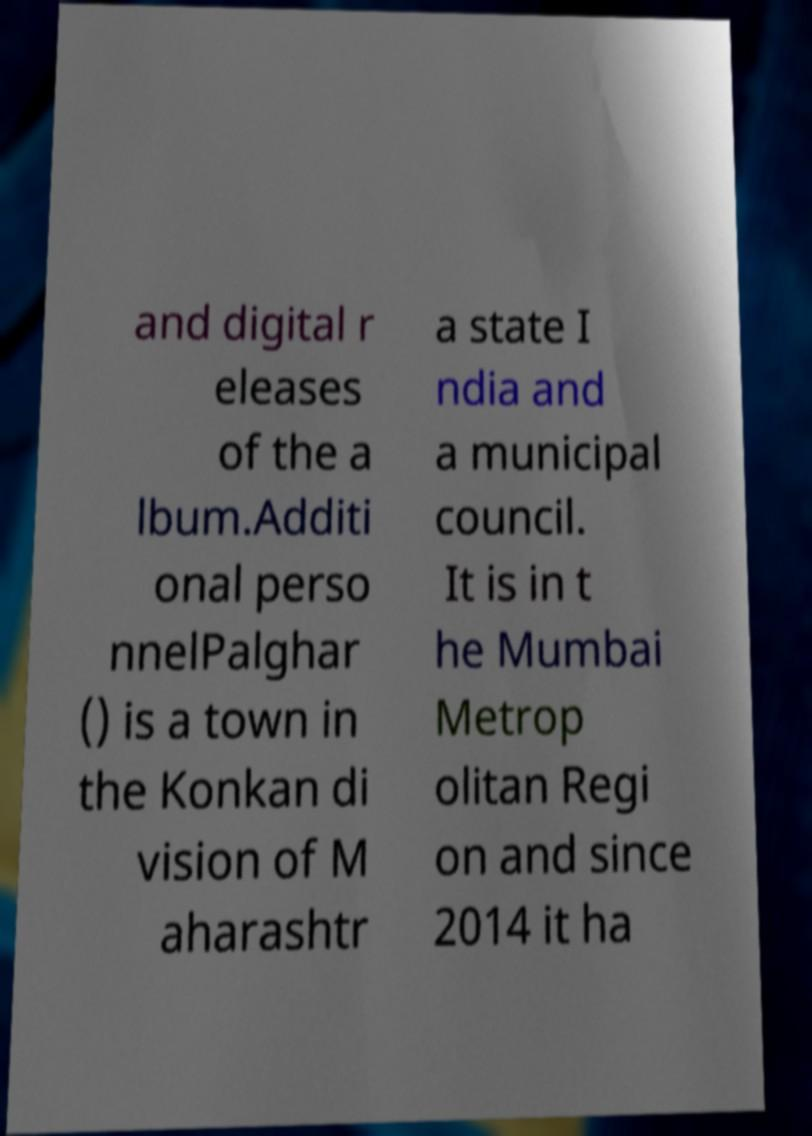There's text embedded in this image that I need extracted. Can you transcribe it verbatim? and digital r eleases of the a lbum.Additi onal perso nnelPalghar () is a town in the Konkan di vision of M aharashtr a state I ndia and a municipal council. It is in t he Mumbai Metrop olitan Regi on and since 2014 it ha 